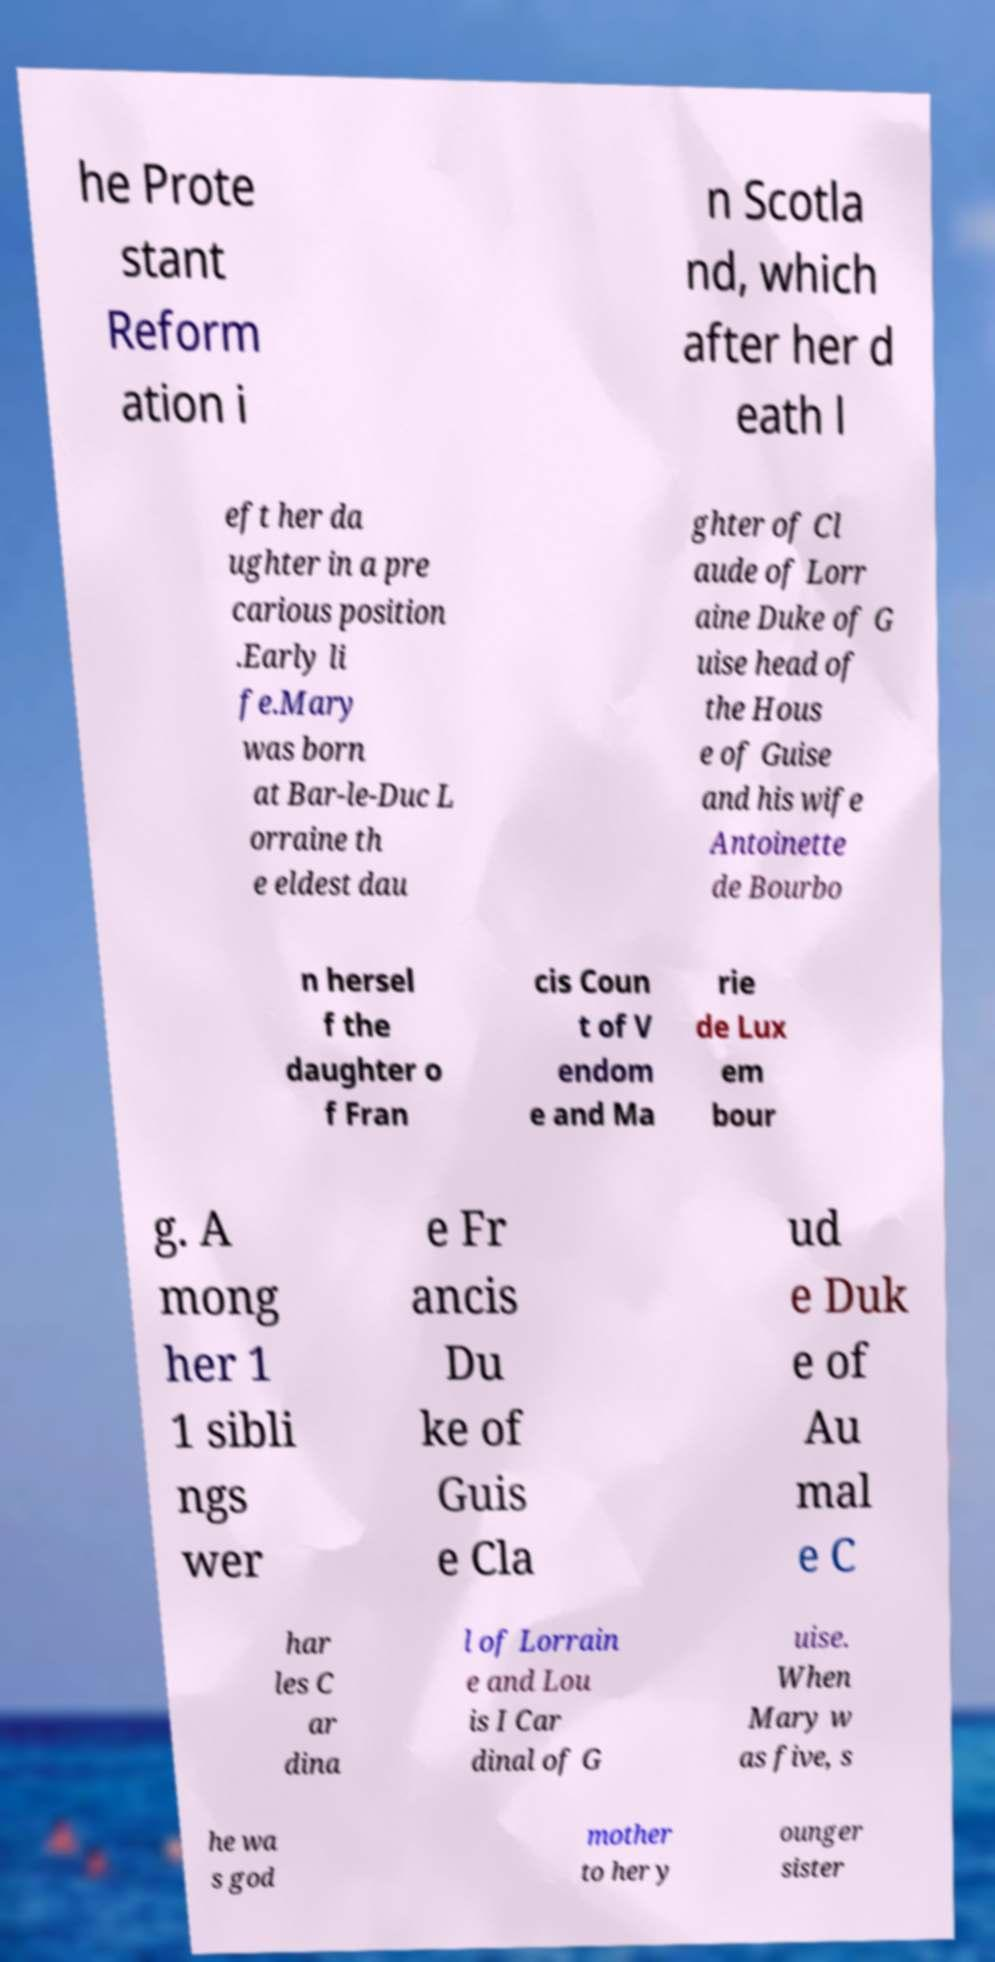Please read and relay the text visible in this image. What does it say? he Prote stant Reform ation i n Scotla nd, which after her d eath l eft her da ughter in a pre carious position .Early li fe.Mary was born at Bar-le-Duc L orraine th e eldest dau ghter of Cl aude of Lorr aine Duke of G uise head of the Hous e of Guise and his wife Antoinette de Bourbo n hersel f the daughter o f Fran cis Coun t of V endom e and Ma rie de Lux em bour g. A mong her 1 1 sibli ngs wer e Fr ancis Du ke of Guis e Cla ud e Duk e of Au mal e C har les C ar dina l of Lorrain e and Lou is I Car dinal of G uise. When Mary w as five, s he wa s god mother to her y ounger sister 